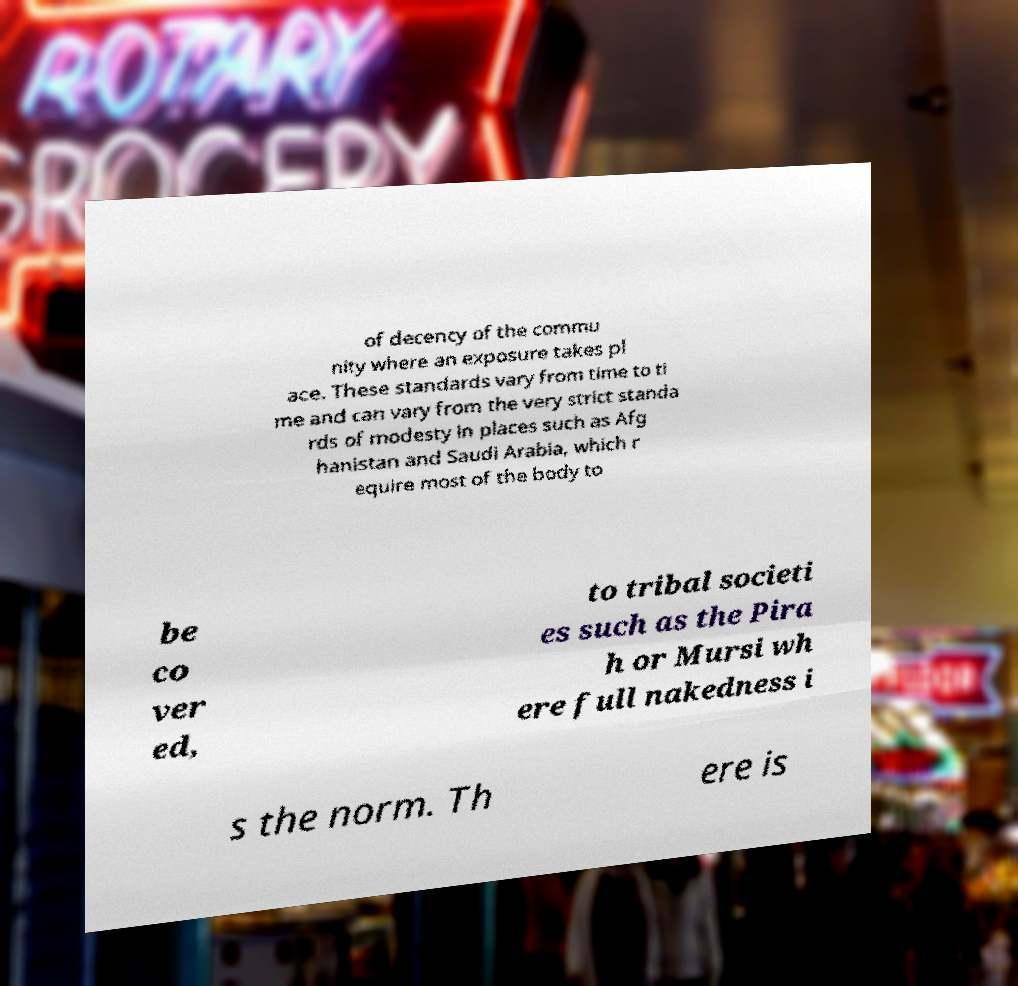What messages or text are displayed in this image? I need them in a readable, typed format. of decency of the commu nity where an exposure takes pl ace. These standards vary from time to ti me and can vary from the very strict standa rds of modesty in places such as Afg hanistan and Saudi Arabia, which r equire most of the body to be co ver ed, to tribal societi es such as the Pira h or Mursi wh ere full nakedness i s the norm. Th ere is 